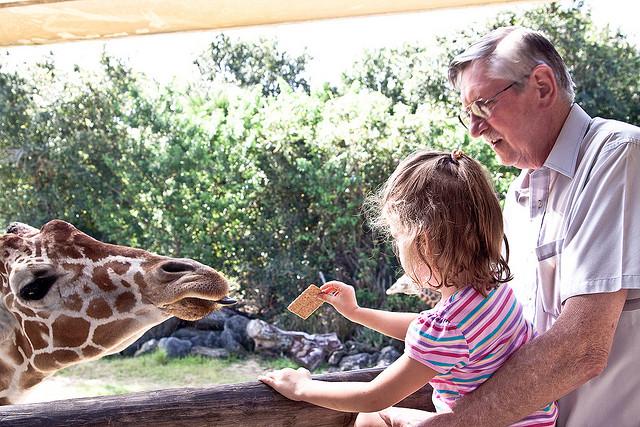What is the girl feeding the giraffe?
Be succinct. Cracker. Is it sunny out?
Keep it brief. Yes. What is in the girl's hand?
Answer briefly. Cracker. 